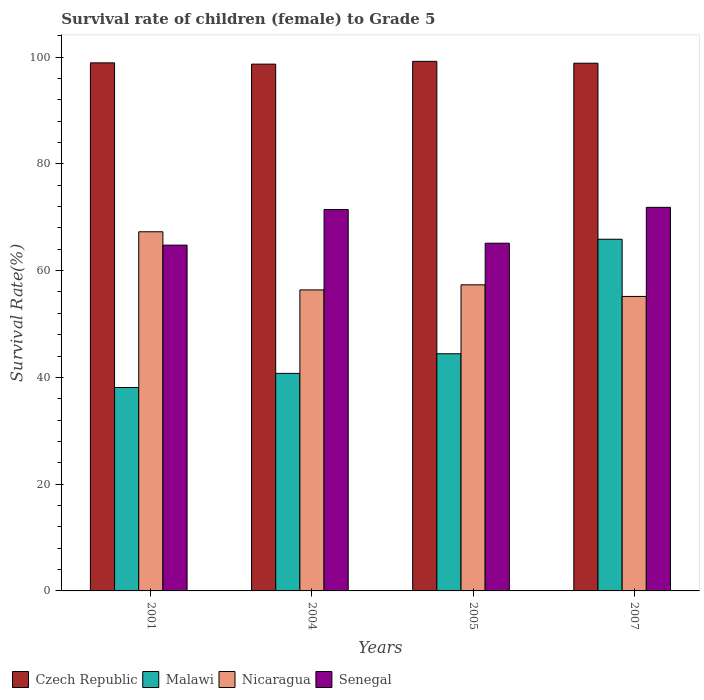How many groups of bars are there?
Ensure brevity in your answer.  4. Are the number of bars on each tick of the X-axis equal?
Your answer should be very brief. Yes. How many bars are there on the 4th tick from the left?
Your response must be concise. 4. What is the survival rate of female children to grade 5 in Senegal in 2001?
Provide a short and direct response. 64.77. Across all years, what is the maximum survival rate of female children to grade 5 in Malawi?
Offer a very short reply. 65.88. Across all years, what is the minimum survival rate of female children to grade 5 in Nicaragua?
Give a very brief answer. 55.16. In which year was the survival rate of female children to grade 5 in Nicaragua minimum?
Ensure brevity in your answer.  2007. What is the total survival rate of female children to grade 5 in Malawi in the graph?
Your answer should be compact. 189.16. What is the difference between the survival rate of female children to grade 5 in Czech Republic in 2001 and that in 2005?
Ensure brevity in your answer.  -0.28. What is the difference between the survival rate of female children to grade 5 in Czech Republic in 2007 and the survival rate of female children to grade 5 in Senegal in 2001?
Make the answer very short. 34.08. What is the average survival rate of female children to grade 5 in Senegal per year?
Give a very brief answer. 68.3. In the year 2005, what is the difference between the survival rate of female children to grade 5 in Nicaragua and survival rate of female children to grade 5 in Czech Republic?
Your answer should be very brief. -41.86. In how many years, is the survival rate of female children to grade 5 in Malawi greater than 92 %?
Give a very brief answer. 0. What is the ratio of the survival rate of female children to grade 5 in Czech Republic in 2001 to that in 2005?
Give a very brief answer. 1. Is the survival rate of female children to grade 5 in Nicaragua in 2004 less than that in 2007?
Ensure brevity in your answer.  No. Is the difference between the survival rate of female children to grade 5 in Nicaragua in 2001 and 2004 greater than the difference between the survival rate of female children to grade 5 in Czech Republic in 2001 and 2004?
Ensure brevity in your answer.  Yes. What is the difference between the highest and the second highest survival rate of female children to grade 5 in Nicaragua?
Your response must be concise. 9.94. What is the difference between the highest and the lowest survival rate of female children to grade 5 in Malawi?
Offer a very short reply. 27.77. In how many years, is the survival rate of female children to grade 5 in Czech Republic greater than the average survival rate of female children to grade 5 in Czech Republic taken over all years?
Make the answer very short. 2. What does the 2nd bar from the left in 2001 represents?
Make the answer very short. Malawi. What does the 1st bar from the right in 2001 represents?
Provide a short and direct response. Senegal. Are all the bars in the graph horizontal?
Make the answer very short. No. How many years are there in the graph?
Your response must be concise. 4. Are the values on the major ticks of Y-axis written in scientific E-notation?
Your answer should be compact. No. Does the graph contain grids?
Your answer should be compact. No. Where does the legend appear in the graph?
Keep it short and to the point. Bottom left. How are the legend labels stacked?
Give a very brief answer. Horizontal. What is the title of the graph?
Give a very brief answer. Survival rate of children (female) to Grade 5. Does "Costa Rica" appear as one of the legend labels in the graph?
Your response must be concise. No. What is the label or title of the Y-axis?
Provide a succinct answer. Survival Rate(%). What is the Survival Rate(%) in Czech Republic in 2001?
Ensure brevity in your answer.  98.92. What is the Survival Rate(%) of Malawi in 2001?
Offer a very short reply. 38.11. What is the Survival Rate(%) of Nicaragua in 2001?
Make the answer very short. 67.28. What is the Survival Rate(%) in Senegal in 2001?
Offer a terse response. 64.77. What is the Survival Rate(%) in Czech Republic in 2004?
Provide a succinct answer. 98.68. What is the Survival Rate(%) of Malawi in 2004?
Your answer should be very brief. 40.75. What is the Survival Rate(%) of Nicaragua in 2004?
Provide a succinct answer. 56.39. What is the Survival Rate(%) of Senegal in 2004?
Ensure brevity in your answer.  71.45. What is the Survival Rate(%) in Czech Republic in 2005?
Offer a terse response. 99.2. What is the Survival Rate(%) in Malawi in 2005?
Ensure brevity in your answer.  44.43. What is the Survival Rate(%) in Nicaragua in 2005?
Your answer should be very brief. 57.34. What is the Survival Rate(%) in Senegal in 2005?
Provide a short and direct response. 65.13. What is the Survival Rate(%) in Czech Republic in 2007?
Ensure brevity in your answer.  98.85. What is the Survival Rate(%) of Malawi in 2007?
Your answer should be compact. 65.88. What is the Survival Rate(%) in Nicaragua in 2007?
Offer a terse response. 55.16. What is the Survival Rate(%) of Senegal in 2007?
Keep it short and to the point. 71.86. Across all years, what is the maximum Survival Rate(%) of Czech Republic?
Keep it short and to the point. 99.2. Across all years, what is the maximum Survival Rate(%) of Malawi?
Ensure brevity in your answer.  65.88. Across all years, what is the maximum Survival Rate(%) of Nicaragua?
Provide a succinct answer. 67.28. Across all years, what is the maximum Survival Rate(%) of Senegal?
Provide a succinct answer. 71.86. Across all years, what is the minimum Survival Rate(%) in Czech Republic?
Make the answer very short. 98.68. Across all years, what is the minimum Survival Rate(%) in Malawi?
Provide a short and direct response. 38.11. Across all years, what is the minimum Survival Rate(%) of Nicaragua?
Keep it short and to the point. 55.16. Across all years, what is the minimum Survival Rate(%) in Senegal?
Ensure brevity in your answer.  64.77. What is the total Survival Rate(%) in Czech Republic in the graph?
Ensure brevity in your answer.  395.65. What is the total Survival Rate(%) of Malawi in the graph?
Your answer should be very brief. 189.16. What is the total Survival Rate(%) in Nicaragua in the graph?
Provide a succinct answer. 236.17. What is the total Survival Rate(%) in Senegal in the graph?
Your answer should be compact. 273.21. What is the difference between the Survival Rate(%) in Czech Republic in 2001 and that in 2004?
Ensure brevity in your answer.  0.24. What is the difference between the Survival Rate(%) of Malawi in 2001 and that in 2004?
Provide a succinct answer. -2.64. What is the difference between the Survival Rate(%) of Nicaragua in 2001 and that in 2004?
Your response must be concise. 10.89. What is the difference between the Survival Rate(%) of Senegal in 2001 and that in 2004?
Ensure brevity in your answer.  -6.68. What is the difference between the Survival Rate(%) of Czech Republic in 2001 and that in 2005?
Your answer should be very brief. -0.28. What is the difference between the Survival Rate(%) in Malawi in 2001 and that in 2005?
Offer a terse response. -6.32. What is the difference between the Survival Rate(%) in Nicaragua in 2001 and that in 2005?
Ensure brevity in your answer.  9.94. What is the difference between the Survival Rate(%) in Senegal in 2001 and that in 2005?
Make the answer very short. -0.36. What is the difference between the Survival Rate(%) of Czech Republic in 2001 and that in 2007?
Provide a succinct answer. 0.07. What is the difference between the Survival Rate(%) of Malawi in 2001 and that in 2007?
Make the answer very short. -27.77. What is the difference between the Survival Rate(%) of Nicaragua in 2001 and that in 2007?
Offer a terse response. 12.11. What is the difference between the Survival Rate(%) of Senegal in 2001 and that in 2007?
Ensure brevity in your answer.  -7.08. What is the difference between the Survival Rate(%) of Czech Republic in 2004 and that in 2005?
Your answer should be very brief. -0.52. What is the difference between the Survival Rate(%) of Malawi in 2004 and that in 2005?
Your answer should be very brief. -3.68. What is the difference between the Survival Rate(%) of Nicaragua in 2004 and that in 2005?
Offer a terse response. -0.95. What is the difference between the Survival Rate(%) of Senegal in 2004 and that in 2005?
Offer a very short reply. 6.31. What is the difference between the Survival Rate(%) of Czech Republic in 2004 and that in 2007?
Your answer should be very brief. -0.17. What is the difference between the Survival Rate(%) of Malawi in 2004 and that in 2007?
Your answer should be compact. -25.13. What is the difference between the Survival Rate(%) of Nicaragua in 2004 and that in 2007?
Provide a short and direct response. 1.23. What is the difference between the Survival Rate(%) of Senegal in 2004 and that in 2007?
Keep it short and to the point. -0.41. What is the difference between the Survival Rate(%) in Czech Republic in 2005 and that in 2007?
Offer a terse response. 0.35. What is the difference between the Survival Rate(%) of Malawi in 2005 and that in 2007?
Your answer should be compact. -21.45. What is the difference between the Survival Rate(%) of Nicaragua in 2005 and that in 2007?
Give a very brief answer. 2.17. What is the difference between the Survival Rate(%) of Senegal in 2005 and that in 2007?
Give a very brief answer. -6.72. What is the difference between the Survival Rate(%) in Czech Republic in 2001 and the Survival Rate(%) in Malawi in 2004?
Offer a very short reply. 58.17. What is the difference between the Survival Rate(%) of Czech Republic in 2001 and the Survival Rate(%) of Nicaragua in 2004?
Provide a short and direct response. 42.53. What is the difference between the Survival Rate(%) in Czech Republic in 2001 and the Survival Rate(%) in Senegal in 2004?
Your answer should be compact. 27.47. What is the difference between the Survival Rate(%) in Malawi in 2001 and the Survival Rate(%) in Nicaragua in 2004?
Give a very brief answer. -18.28. What is the difference between the Survival Rate(%) of Malawi in 2001 and the Survival Rate(%) of Senegal in 2004?
Provide a succinct answer. -33.34. What is the difference between the Survival Rate(%) of Nicaragua in 2001 and the Survival Rate(%) of Senegal in 2004?
Your answer should be compact. -4.17. What is the difference between the Survival Rate(%) in Czech Republic in 2001 and the Survival Rate(%) in Malawi in 2005?
Offer a terse response. 54.49. What is the difference between the Survival Rate(%) of Czech Republic in 2001 and the Survival Rate(%) of Nicaragua in 2005?
Ensure brevity in your answer.  41.58. What is the difference between the Survival Rate(%) in Czech Republic in 2001 and the Survival Rate(%) in Senegal in 2005?
Your answer should be very brief. 33.78. What is the difference between the Survival Rate(%) of Malawi in 2001 and the Survival Rate(%) of Nicaragua in 2005?
Offer a very short reply. -19.23. What is the difference between the Survival Rate(%) of Malawi in 2001 and the Survival Rate(%) of Senegal in 2005?
Offer a terse response. -27.03. What is the difference between the Survival Rate(%) in Nicaragua in 2001 and the Survival Rate(%) in Senegal in 2005?
Provide a short and direct response. 2.14. What is the difference between the Survival Rate(%) of Czech Republic in 2001 and the Survival Rate(%) of Malawi in 2007?
Your answer should be very brief. 33.04. What is the difference between the Survival Rate(%) of Czech Republic in 2001 and the Survival Rate(%) of Nicaragua in 2007?
Keep it short and to the point. 43.75. What is the difference between the Survival Rate(%) of Czech Republic in 2001 and the Survival Rate(%) of Senegal in 2007?
Ensure brevity in your answer.  27.06. What is the difference between the Survival Rate(%) of Malawi in 2001 and the Survival Rate(%) of Nicaragua in 2007?
Ensure brevity in your answer.  -17.06. What is the difference between the Survival Rate(%) in Malawi in 2001 and the Survival Rate(%) in Senegal in 2007?
Your answer should be very brief. -33.75. What is the difference between the Survival Rate(%) in Nicaragua in 2001 and the Survival Rate(%) in Senegal in 2007?
Your answer should be very brief. -4.58. What is the difference between the Survival Rate(%) in Czech Republic in 2004 and the Survival Rate(%) in Malawi in 2005?
Ensure brevity in your answer.  54.26. What is the difference between the Survival Rate(%) of Czech Republic in 2004 and the Survival Rate(%) of Nicaragua in 2005?
Give a very brief answer. 41.34. What is the difference between the Survival Rate(%) of Czech Republic in 2004 and the Survival Rate(%) of Senegal in 2005?
Make the answer very short. 33.55. What is the difference between the Survival Rate(%) in Malawi in 2004 and the Survival Rate(%) in Nicaragua in 2005?
Offer a terse response. -16.59. What is the difference between the Survival Rate(%) in Malawi in 2004 and the Survival Rate(%) in Senegal in 2005?
Offer a very short reply. -24.39. What is the difference between the Survival Rate(%) in Nicaragua in 2004 and the Survival Rate(%) in Senegal in 2005?
Your answer should be very brief. -8.75. What is the difference between the Survival Rate(%) of Czech Republic in 2004 and the Survival Rate(%) of Malawi in 2007?
Your answer should be very brief. 32.8. What is the difference between the Survival Rate(%) in Czech Republic in 2004 and the Survival Rate(%) in Nicaragua in 2007?
Make the answer very short. 43.52. What is the difference between the Survival Rate(%) in Czech Republic in 2004 and the Survival Rate(%) in Senegal in 2007?
Make the answer very short. 26.83. What is the difference between the Survival Rate(%) in Malawi in 2004 and the Survival Rate(%) in Nicaragua in 2007?
Offer a terse response. -14.41. What is the difference between the Survival Rate(%) in Malawi in 2004 and the Survival Rate(%) in Senegal in 2007?
Your answer should be very brief. -31.11. What is the difference between the Survival Rate(%) in Nicaragua in 2004 and the Survival Rate(%) in Senegal in 2007?
Ensure brevity in your answer.  -15.47. What is the difference between the Survival Rate(%) of Czech Republic in 2005 and the Survival Rate(%) of Malawi in 2007?
Keep it short and to the point. 33.32. What is the difference between the Survival Rate(%) of Czech Republic in 2005 and the Survival Rate(%) of Nicaragua in 2007?
Ensure brevity in your answer.  44.04. What is the difference between the Survival Rate(%) of Czech Republic in 2005 and the Survival Rate(%) of Senegal in 2007?
Keep it short and to the point. 27.34. What is the difference between the Survival Rate(%) of Malawi in 2005 and the Survival Rate(%) of Nicaragua in 2007?
Keep it short and to the point. -10.74. What is the difference between the Survival Rate(%) in Malawi in 2005 and the Survival Rate(%) in Senegal in 2007?
Offer a terse response. -27.43. What is the difference between the Survival Rate(%) of Nicaragua in 2005 and the Survival Rate(%) of Senegal in 2007?
Offer a very short reply. -14.52. What is the average Survival Rate(%) in Czech Republic per year?
Your answer should be compact. 98.91. What is the average Survival Rate(%) in Malawi per year?
Make the answer very short. 47.29. What is the average Survival Rate(%) of Nicaragua per year?
Provide a short and direct response. 59.04. What is the average Survival Rate(%) of Senegal per year?
Your answer should be very brief. 68.3. In the year 2001, what is the difference between the Survival Rate(%) of Czech Republic and Survival Rate(%) of Malawi?
Offer a very short reply. 60.81. In the year 2001, what is the difference between the Survival Rate(%) in Czech Republic and Survival Rate(%) in Nicaragua?
Make the answer very short. 31.64. In the year 2001, what is the difference between the Survival Rate(%) of Czech Republic and Survival Rate(%) of Senegal?
Provide a short and direct response. 34.15. In the year 2001, what is the difference between the Survival Rate(%) in Malawi and Survival Rate(%) in Nicaragua?
Make the answer very short. -29.17. In the year 2001, what is the difference between the Survival Rate(%) of Malawi and Survival Rate(%) of Senegal?
Your answer should be very brief. -26.67. In the year 2001, what is the difference between the Survival Rate(%) of Nicaragua and Survival Rate(%) of Senegal?
Your answer should be very brief. 2.51. In the year 2004, what is the difference between the Survival Rate(%) in Czech Republic and Survival Rate(%) in Malawi?
Give a very brief answer. 57.93. In the year 2004, what is the difference between the Survival Rate(%) of Czech Republic and Survival Rate(%) of Nicaragua?
Offer a very short reply. 42.29. In the year 2004, what is the difference between the Survival Rate(%) in Czech Republic and Survival Rate(%) in Senegal?
Give a very brief answer. 27.23. In the year 2004, what is the difference between the Survival Rate(%) in Malawi and Survival Rate(%) in Nicaragua?
Make the answer very short. -15.64. In the year 2004, what is the difference between the Survival Rate(%) of Malawi and Survival Rate(%) of Senegal?
Your response must be concise. -30.7. In the year 2004, what is the difference between the Survival Rate(%) in Nicaragua and Survival Rate(%) in Senegal?
Offer a terse response. -15.06. In the year 2005, what is the difference between the Survival Rate(%) in Czech Republic and Survival Rate(%) in Malawi?
Offer a terse response. 54.77. In the year 2005, what is the difference between the Survival Rate(%) in Czech Republic and Survival Rate(%) in Nicaragua?
Offer a very short reply. 41.86. In the year 2005, what is the difference between the Survival Rate(%) in Czech Republic and Survival Rate(%) in Senegal?
Offer a very short reply. 34.07. In the year 2005, what is the difference between the Survival Rate(%) of Malawi and Survival Rate(%) of Nicaragua?
Ensure brevity in your answer.  -12.91. In the year 2005, what is the difference between the Survival Rate(%) in Malawi and Survival Rate(%) in Senegal?
Make the answer very short. -20.71. In the year 2005, what is the difference between the Survival Rate(%) in Nicaragua and Survival Rate(%) in Senegal?
Your answer should be compact. -7.8. In the year 2007, what is the difference between the Survival Rate(%) in Czech Republic and Survival Rate(%) in Malawi?
Offer a very short reply. 32.97. In the year 2007, what is the difference between the Survival Rate(%) in Czech Republic and Survival Rate(%) in Nicaragua?
Provide a succinct answer. 43.69. In the year 2007, what is the difference between the Survival Rate(%) in Czech Republic and Survival Rate(%) in Senegal?
Make the answer very short. 27. In the year 2007, what is the difference between the Survival Rate(%) in Malawi and Survival Rate(%) in Nicaragua?
Your answer should be very brief. 10.71. In the year 2007, what is the difference between the Survival Rate(%) of Malawi and Survival Rate(%) of Senegal?
Keep it short and to the point. -5.98. In the year 2007, what is the difference between the Survival Rate(%) in Nicaragua and Survival Rate(%) in Senegal?
Your answer should be very brief. -16.69. What is the ratio of the Survival Rate(%) of Malawi in 2001 to that in 2004?
Keep it short and to the point. 0.94. What is the ratio of the Survival Rate(%) in Nicaragua in 2001 to that in 2004?
Offer a terse response. 1.19. What is the ratio of the Survival Rate(%) in Senegal in 2001 to that in 2004?
Your response must be concise. 0.91. What is the ratio of the Survival Rate(%) in Czech Republic in 2001 to that in 2005?
Offer a very short reply. 1. What is the ratio of the Survival Rate(%) in Malawi in 2001 to that in 2005?
Provide a short and direct response. 0.86. What is the ratio of the Survival Rate(%) of Nicaragua in 2001 to that in 2005?
Offer a very short reply. 1.17. What is the ratio of the Survival Rate(%) in Malawi in 2001 to that in 2007?
Offer a very short reply. 0.58. What is the ratio of the Survival Rate(%) in Nicaragua in 2001 to that in 2007?
Offer a very short reply. 1.22. What is the ratio of the Survival Rate(%) in Senegal in 2001 to that in 2007?
Ensure brevity in your answer.  0.9. What is the ratio of the Survival Rate(%) in Malawi in 2004 to that in 2005?
Offer a very short reply. 0.92. What is the ratio of the Survival Rate(%) in Nicaragua in 2004 to that in 2005?
Ensure brevity in your answer.  0.98. What is the ratio of the Survival Rate(%) in Senegal in 2004 to that in 2005?
Your response must be concise. 1.1. What is the ratio of the Survival Rate(%) of Czech Republic in 2004 to that in 2007?
Offer a terse response. 1. What is the ratio of the Survival Rate(%) of Malawi in 2004 to that in 2007?
Offer a terse response. 0.62. What is the ratio of the Survival Rate(%) of Nicaragua in 2004 to that in 2007?
Provide a short and direct response. 1.02. What is the ratio of the Survival Rate(%) in Czech Republic in 2005 to that in 2007?
Provide a short and direct response. 1. What is the ratio of the Survival Rate(%) of Malawi in 2005 to that in 2007?
Give a very brief answer. 0.67. What is the ratio of the Survival Rate(%) of Nicaragua in 2005 to that in 2007?
Ensure brevity in your answer.  1.04. What is the ratio of the Survival Rate(%) of Senegal in 2005 to that in 2007?
Give a very brief answer. 0.91. What is the difference between the highest and the second highest Survival Rate(%) of Czech Republic?
Your response must be concise. 0.28. What is the difference between the highest and the second highest Survival Rate(%) in Malawi?
Keep it short and to the point. 21.45. What is the difference between the highest and the second highest Survival Rate(%) in Nicaragua?
Give a very brief answer. 9.94. What is the difference between the highest and the second highest Survival Rate(%) of Senegal?
Provide a short and direct response. 0.41. What is the difference between the highest and the lowest Survival Rate(%) of Czech Republic?
Ensure brevity in your answer.  0.52. What is the difference between the highest and the lowest Survival Rate(%) in Malawi?
Offer a terse response. 27.77. What is the difference between the highest and the lowest Survival Rate(%) of Nicaragua?
Make the answer very short. 12.11. What is the difference between the highest and the lowest Survival Rate(%) in Senegal?
Provide a succinct answer. 7.08. 